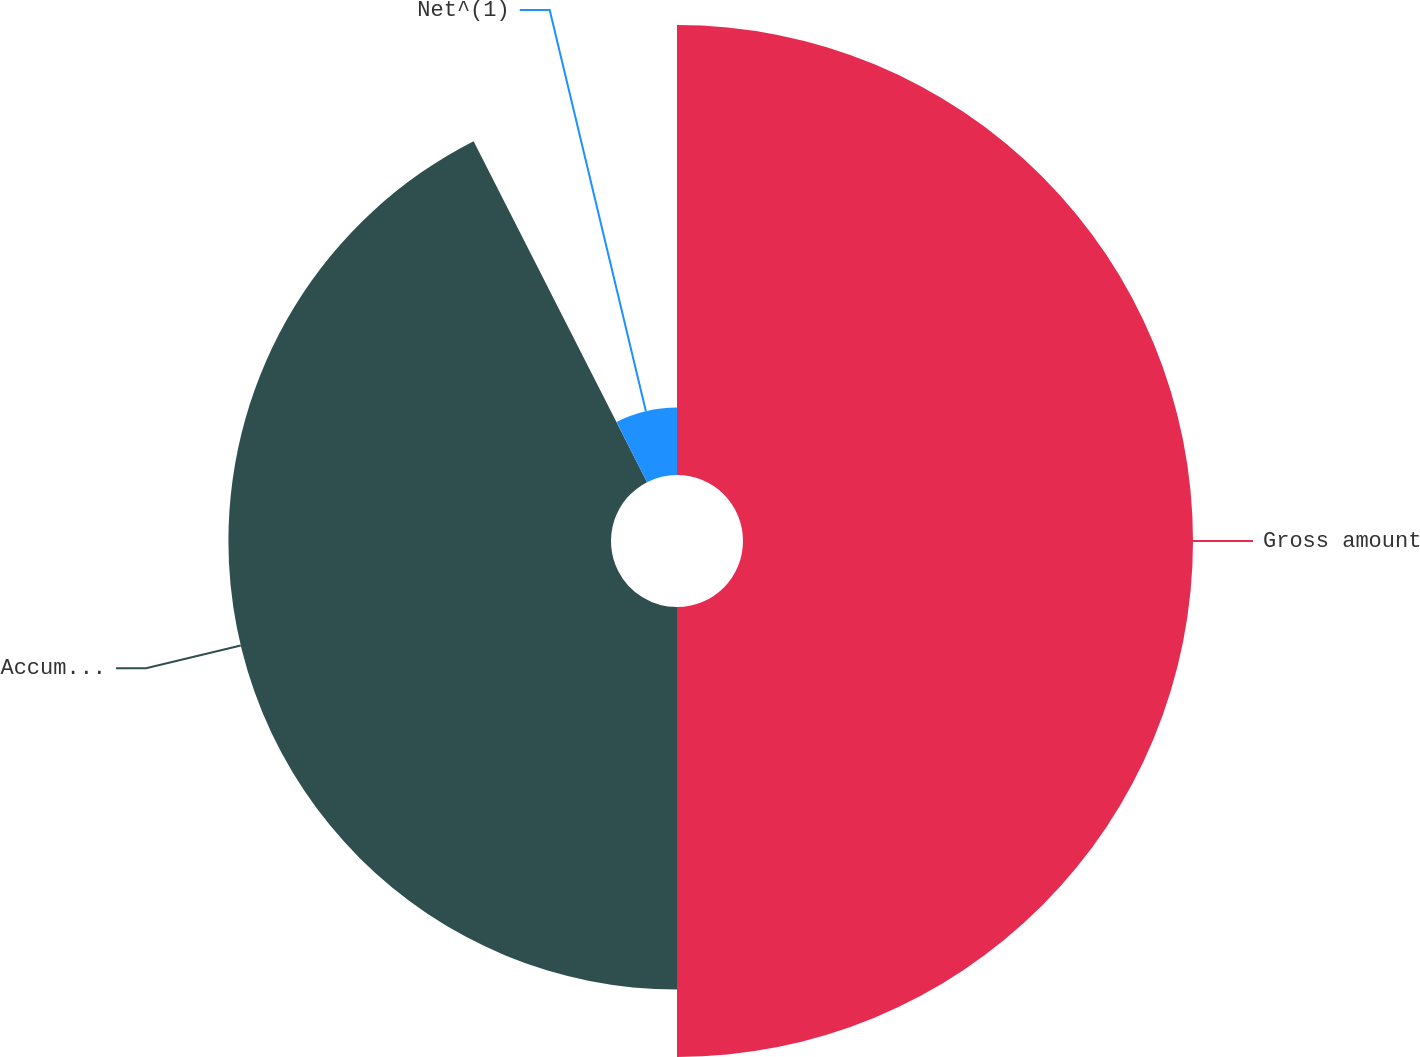Convert chart. <chart><loc_0><loc_0><loc_500><loc_500><pie_chart><fcel>Gross amount<fcel>Accumulated amortization<fcel>Net^(1)<nl><fcel>50.0%<fcel>42.51%<fcel>7.49%<nl></chart> 